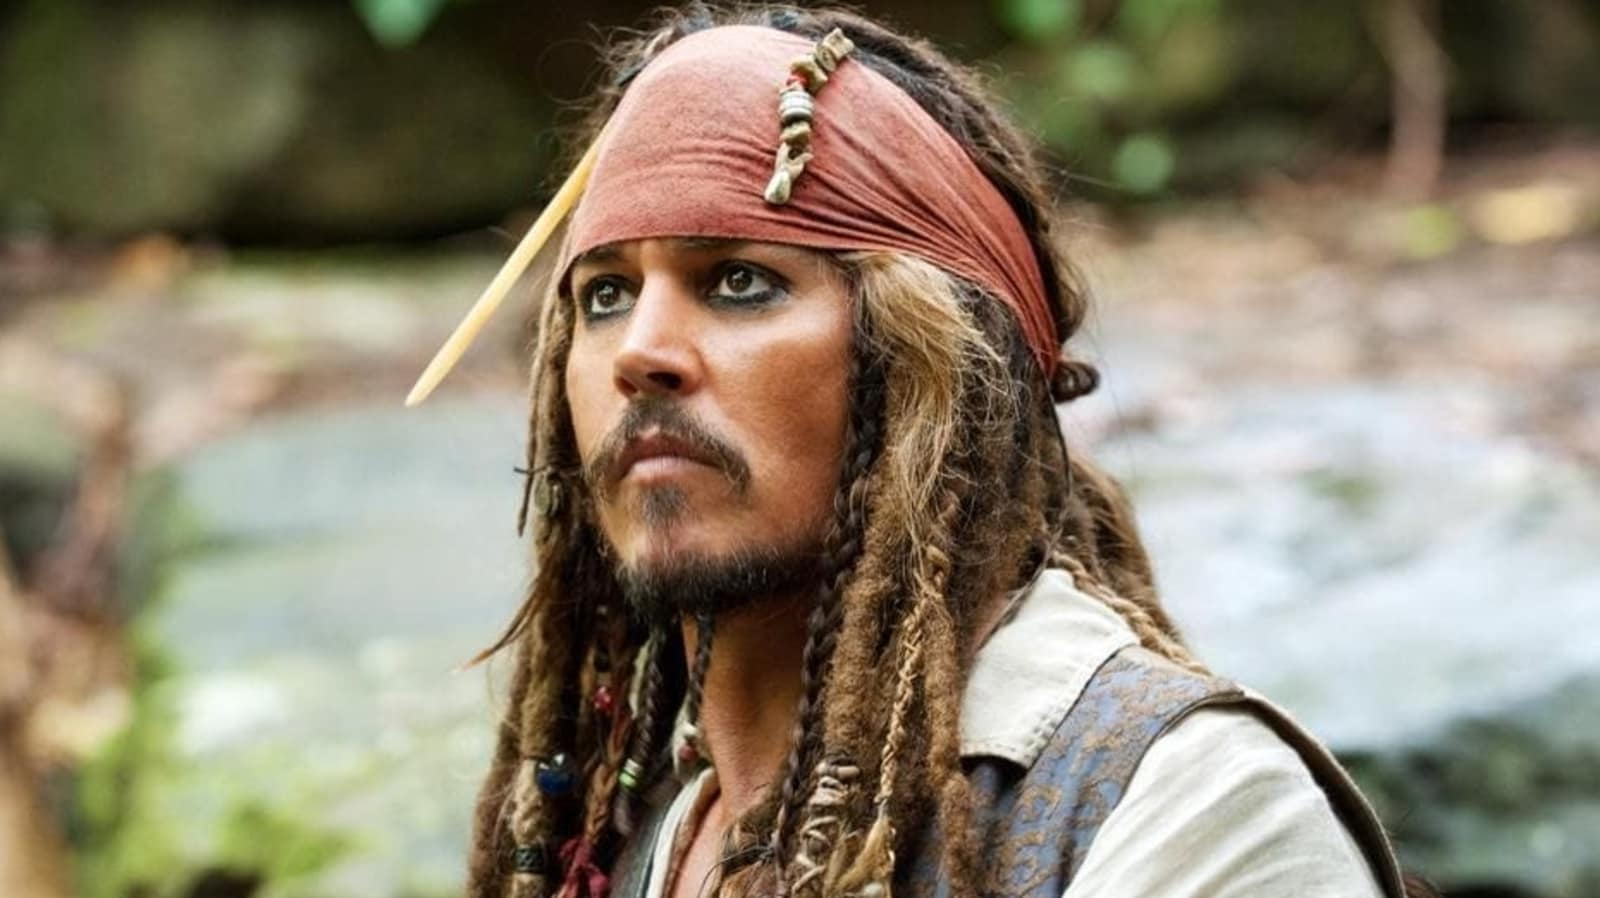What do the character's accessories tell us about his personality or backstory? The character's accessories, including the red bandana adorned with a feather, the dreadlocked hair, and the brown vest, all contribute to crafting an image of a seasoned and adventurous pirate. These items suggest a life spent at sea, filled with countless voyages and encounters. The feathers could represent trophies from past victories, while the worn and practical clothing indicates a person who is always ready for action. His goatee and the beads in his hair signify a distinctive style, showcasing a flamboyant yet rugged persona. How do you think the character acquired these accessories? It's fascinating to imagine how the character might have acquired these accessories. The bandana could have been won in a daring gamble, the feather a spoil from a rare bird captured during a voyage to a distant land. The beads and trinkets intertwined in his dreadlocks might each tell a story of various adventures and encounters - gifts from allies, spoils from vanquished foes, or treasures found in sunken chests. Each item is likely imbued with a history, contributing to the mystique and legend of Captain Jack Sparrow. 